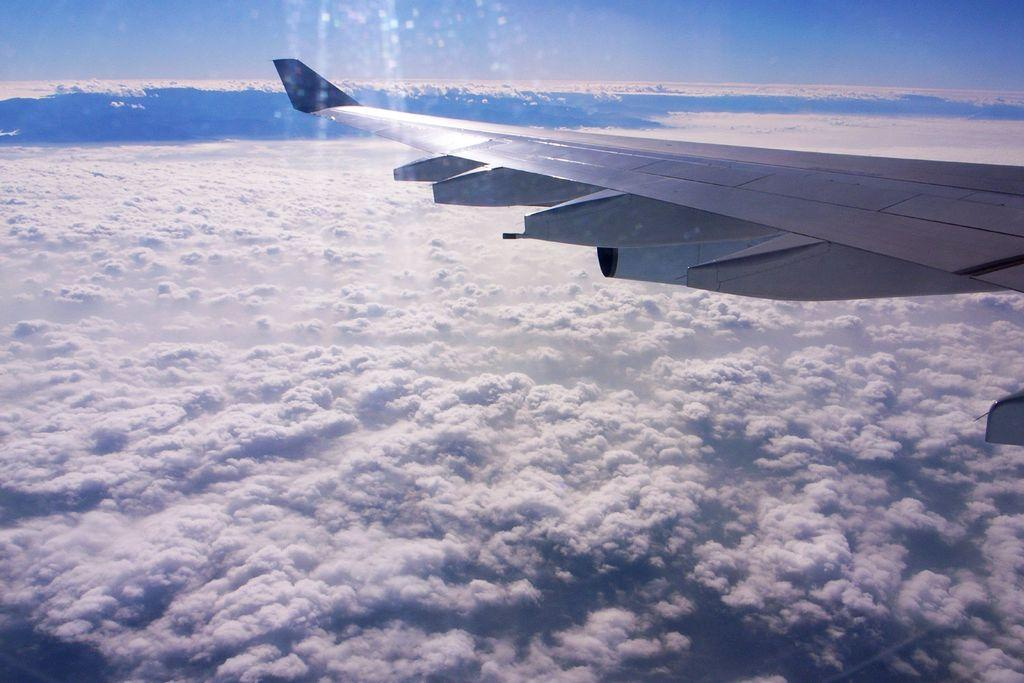What can be seen in the background of the image? The sky is visible in the image. What is present in the sky in the image? There are clouds in the image. What is located on the right side of the image? There is a partial part of an airplane on the right side of the image. What type of butter is being spread on the bike in the image? There is no bike or butter present in the image. Are there any flowers visible in the image? No, there are no flowers visible in the image. 